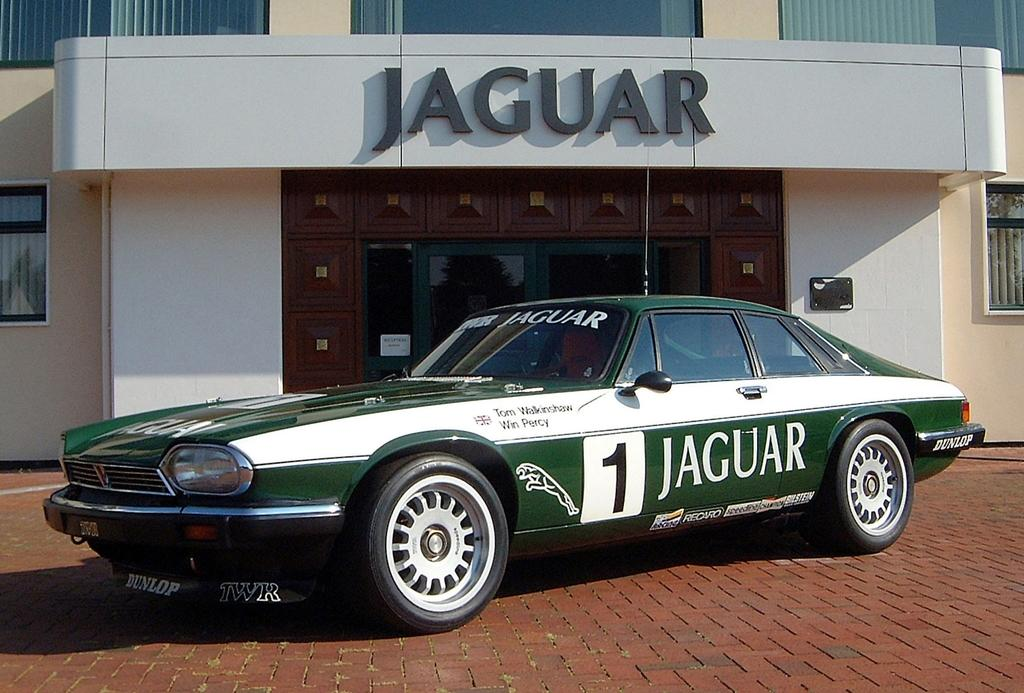What is the main subject in the middle of the image? There is a car in the middle of the image. What can be seen in the background of the image? There are glass doors and a board visible in the background of the image. What type of structure is visible in the background? There is a building visible in the background of the image. What type of operation is being performed by the laborer in the image? There is no laborer or operation present in the image. Is the building in the background a prison? The image does not provide enough information to determine the type of building in the background, so it cannot be confirmed if it is a prison or not. 